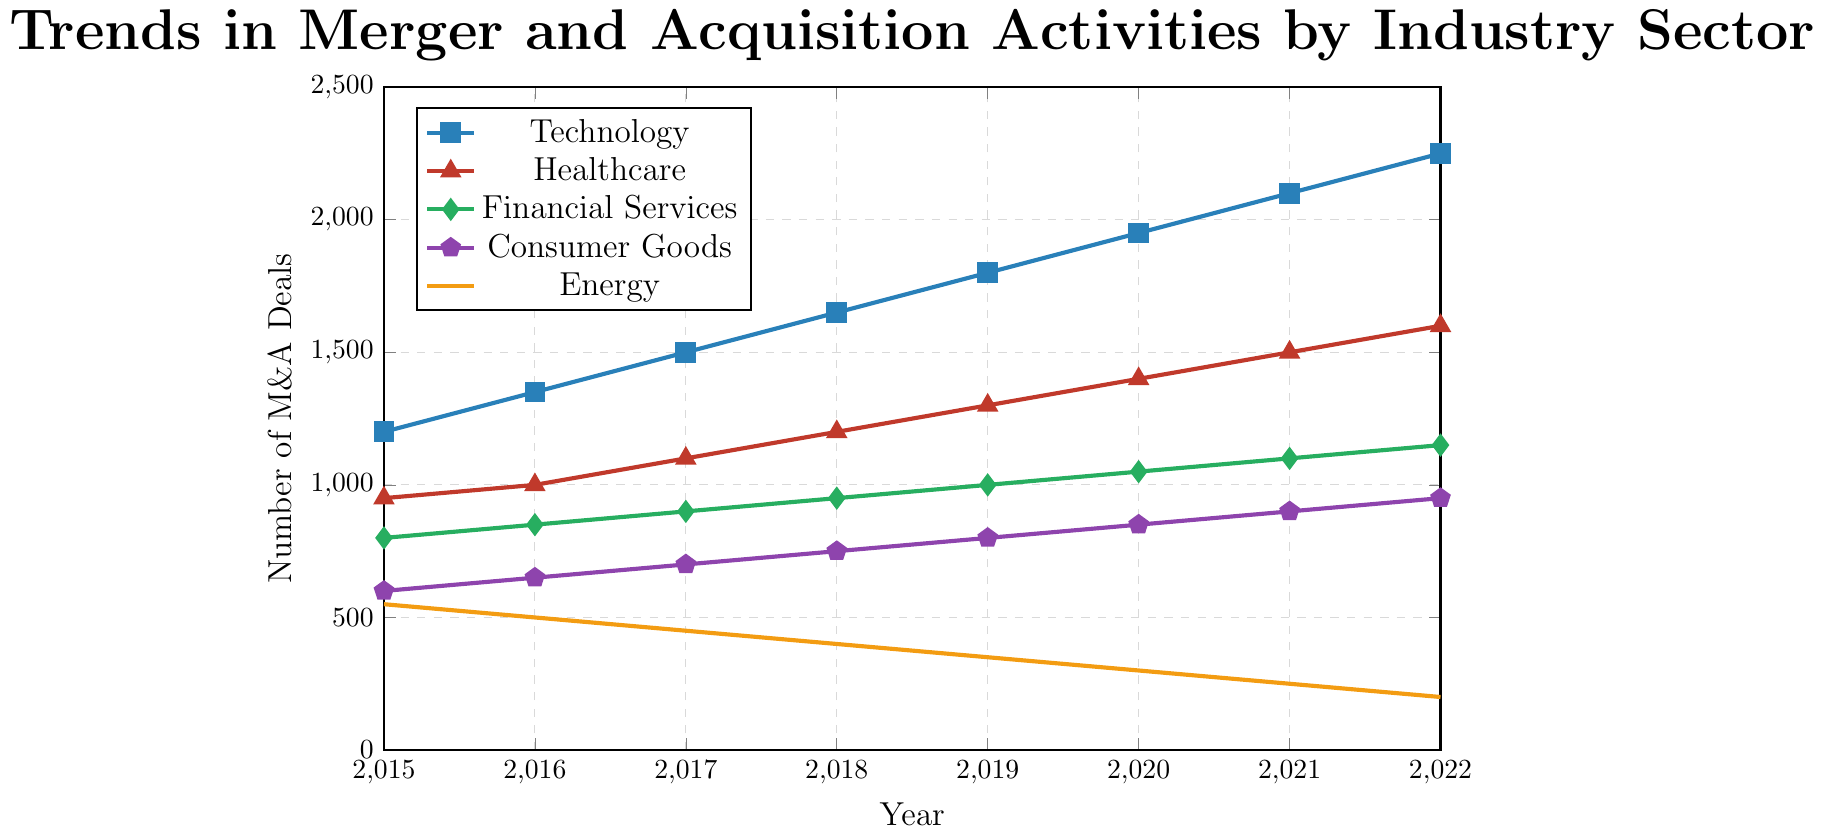What's the trend in the number of M&A deals in the Technology sector from 2015 to 2022? The number of M&A deals in the Technology sector increases each year from 1200 in 2015 to 2250 in 2022. This shows a consistent upward trend without any decline.
Answer: Increasing trend Which sector had the highest number of M&A deals in 2020? In 2020, the Technology sector had the highest number of M&A deals with 1950, followed by Healthcare with 1400, Financial Services with 1050, Consumer Goods with 850, and Energy with 300.
Answer: Technology How many more M&A deals were there in Healthcare than in Energy in 2019? In 2019, there were 1300 M&A deals in Healthcare and 350 in Energy. The difference is 1300 - 350 = 950.
Answer: 950 Compare the trend between Consumer Goods and Financial Services sectors from 2015 to 2022. Both the Consumer Goods and Financial Services sectors showed a gradual increase in M&A deals from 2015 to 2022. However, Financial Services started at 800 deals in 2015 and ended at 1150 in 2022, whereas Consumer Goods started at 600 and ended at 950 over the same period.
Answer: Both increased, Financial Services more Which sector showed a declining trend in M&A deals from 2015 to 2022? The Energy sector showed a declining trend, starting at 550 deals in 2015 and dropping consistently to 200 deals in 2022.
Answer: Energy What's the average number of M&A deals in the Technology sector over the years shown? The yearly deal counts are: 1200, 1350, 1500, 1650, 1800, 1950, 2100, and 2250. The average is (1200 + 1350 + 1500 + 1650 + 1800 + 1950 + 2100 + 2250) / 8 = 1725.
Answer: 1725 Which year did Consumer Goods surpass 800 M&A deals, and by how many? Consumer Goods surpassed 800 M&A deals in 2019 with exactly 800 deals. It increased further in 2020, with 850 deals.
Answer: 2019 by 0 What is the combined number of M&A deals in the Financial Services and Energy sectors in 2022? In 2022, Financial Services had 1150 deals and Energy had 200 deals. The combined number is 1150 + 200 = 1350.
Answer: 1350 Which sector had the least amount of change in the number of M&A deals from 2015 to 2022? The Financial Services sector had the least amount of change, increasing from 800 in 2015 to 1150 in 2022, a total change of 350 deals. Other sectors had larger total changes.
Answer: Financial Services How did the number of M&A deals in the Healthcare sector change between 2018 and 2019? The Healthcare sector increased from 1200 deals in 2018 to 1300 deals in 2019. The change is 1300 - 1200 = 100.
Answer: Increased by 100 